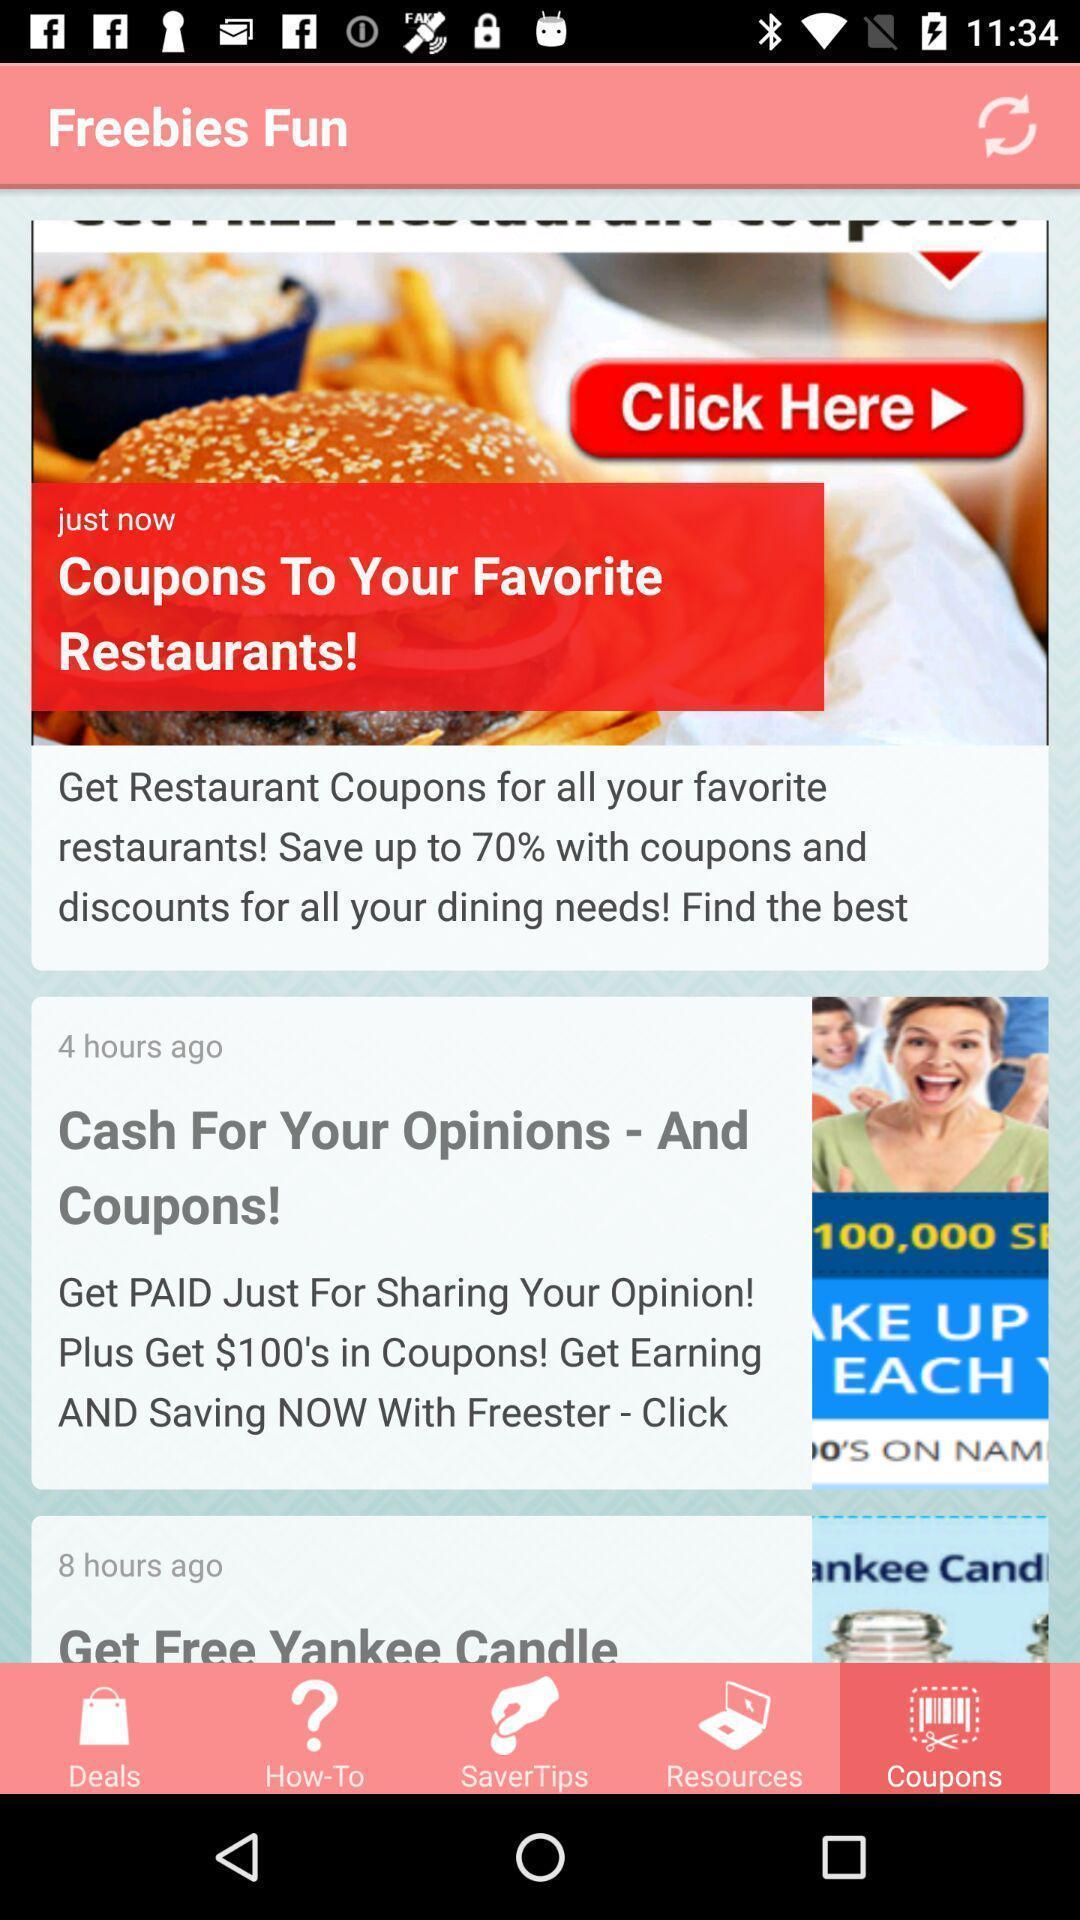Provide a detailed account of this screenshot. Screen displaying latest articles information. 